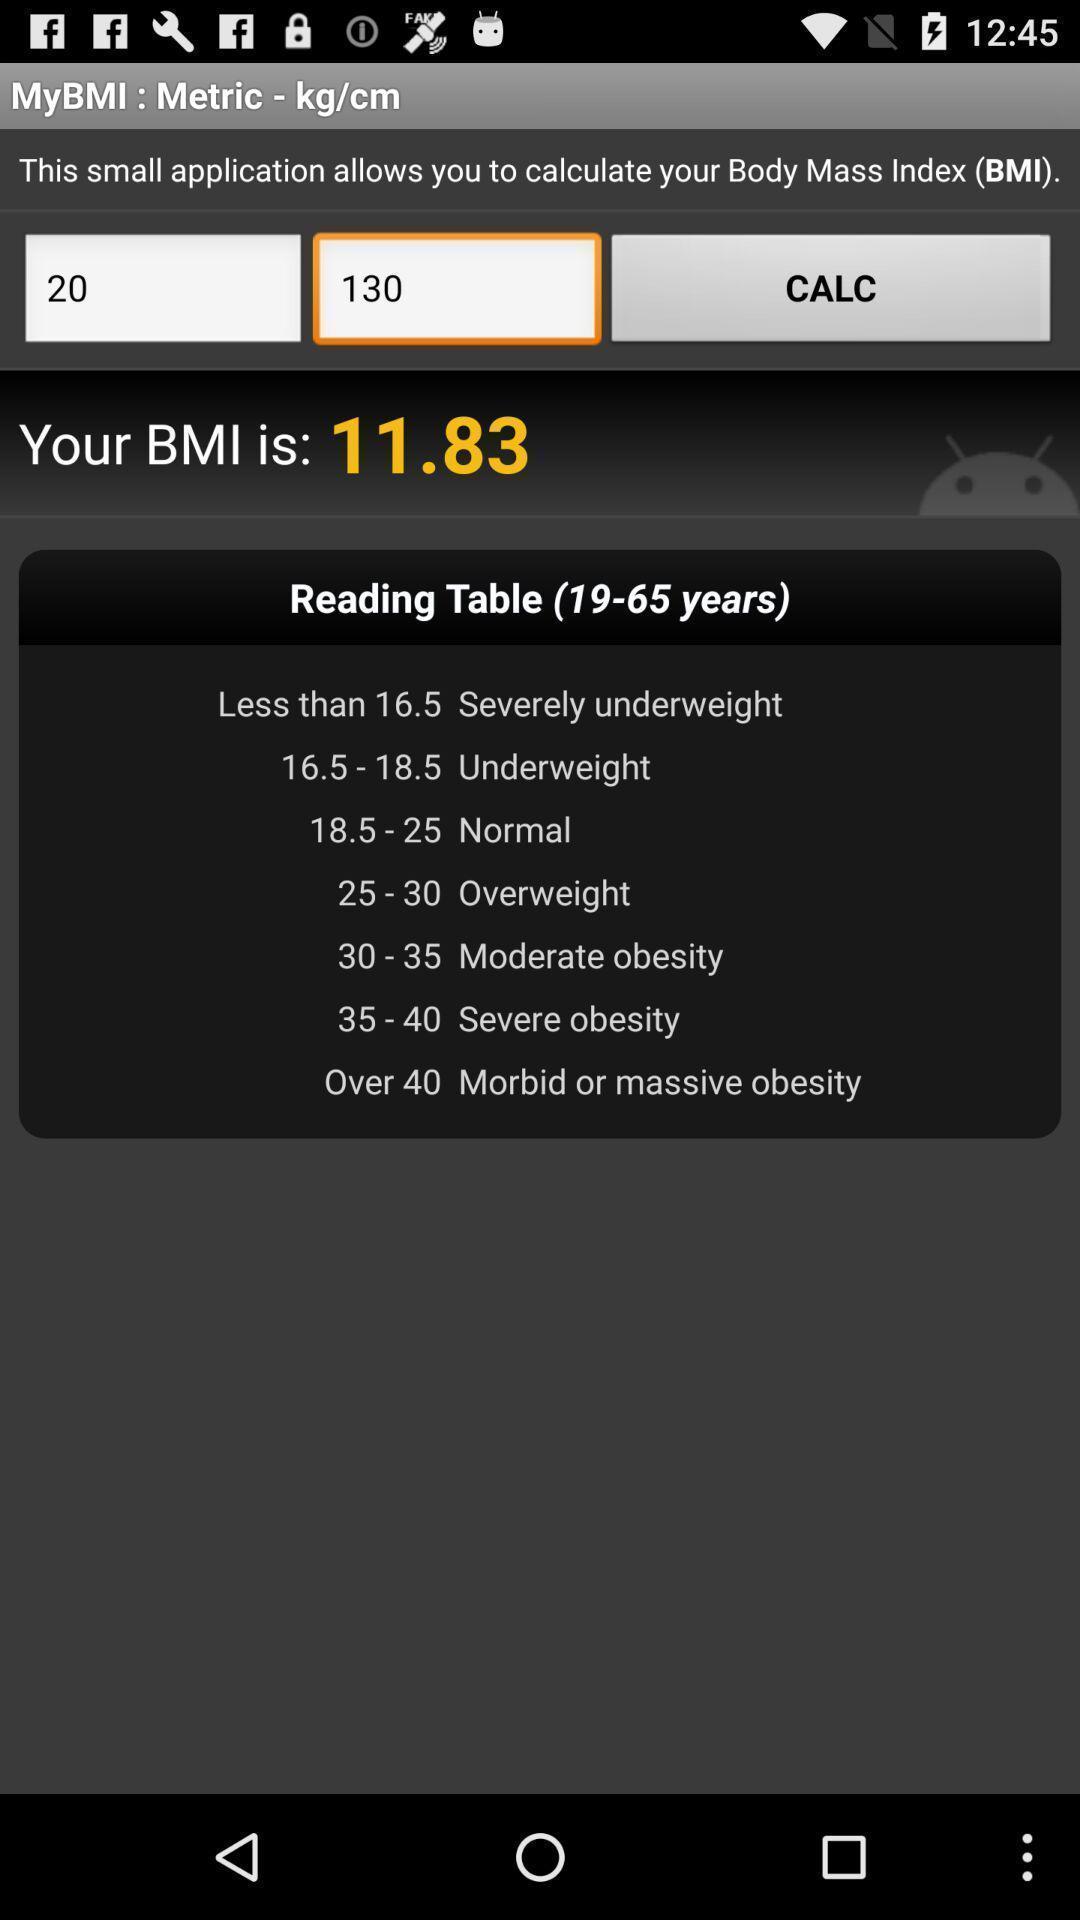Provide a detailed account of this screenshot. Page displaying metrics. 